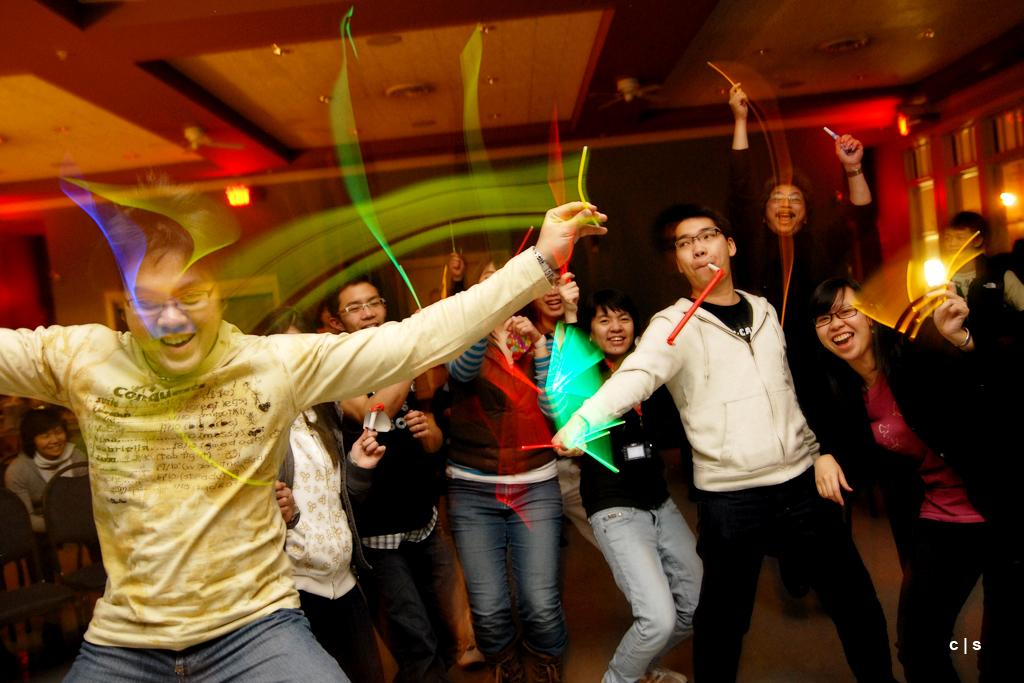What type of setting is depicted in the image? The image is an inside view. What are the people in the image doing? There are many people dancing on the floor. What can be seen in the background of the image? There are lights and a wall visible in the background. What is your uncle's favorite dance move at the event, and why does he enjoy it? There is no reference to an uncle or an event in the image, so it's not possible to answer that question. 